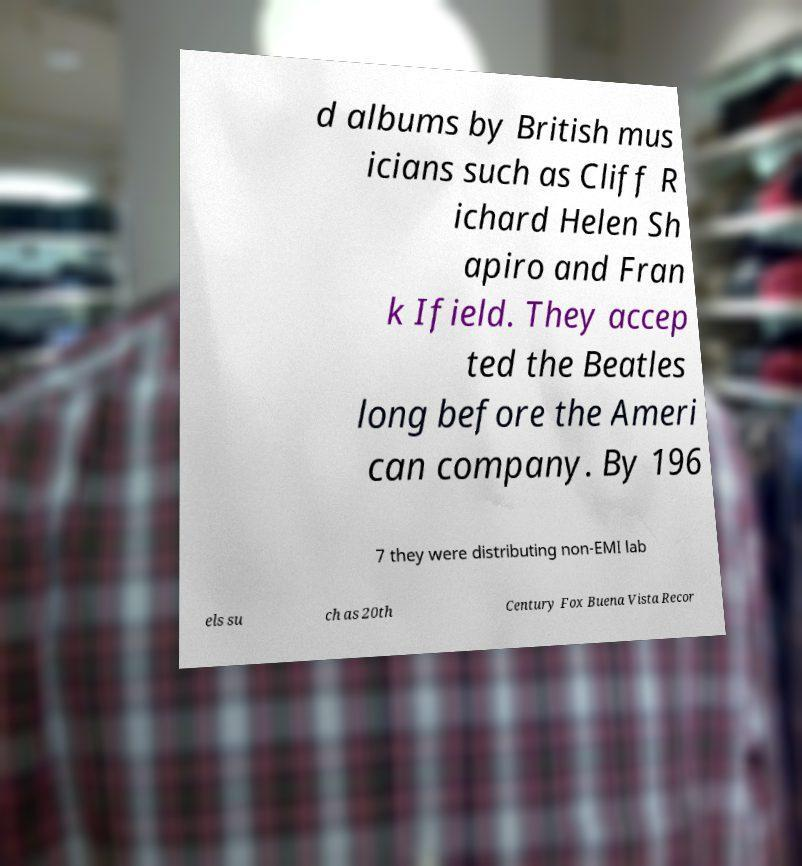Please read and relay the text visible in this image. What does it say? d albums by British mus icians such as Cliff R ichard Helen Sh apiro and Fran k Ifield. They accep ted the Beatles long before the Ameri can company. By 196 7 they were distributing non-EMI lab els su ch as 20th Century Fox Buena Vista Recor 